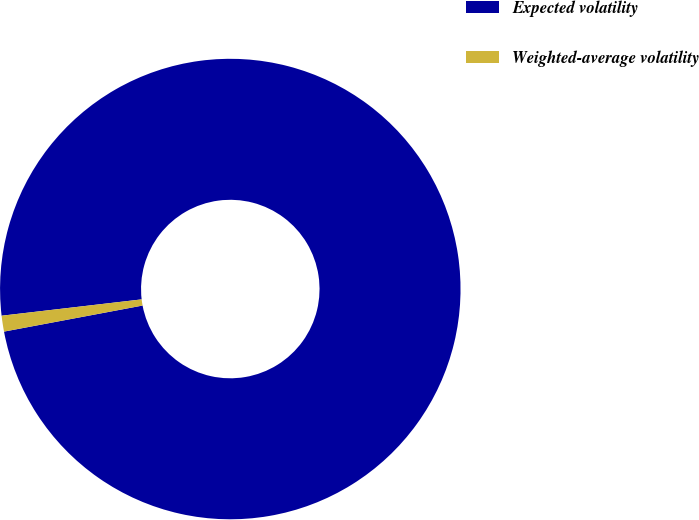<chart> <loc_0><loc_0><loc_500><loc_500><pie_chart><fcel>Expected volatility<fcel>Weighted-average volatility<nl><fcel>98.89%<fcel>1.11%<nl></chart> 